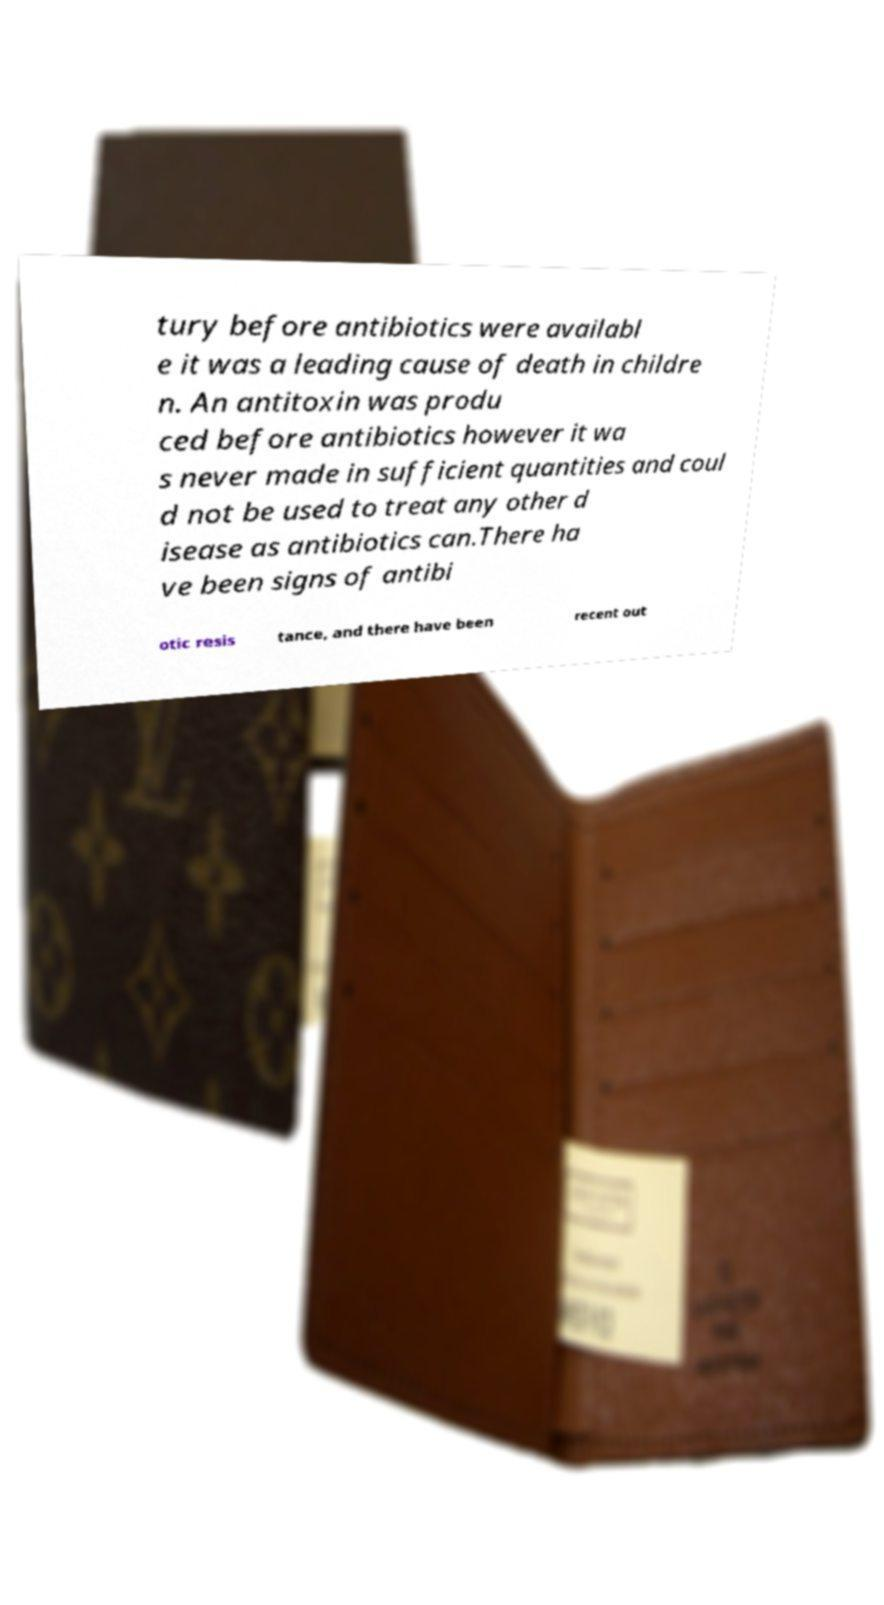I need the written content from this picture converted into text. Can you do that? tury before antibiotics were availabl e it was a leading cause of death in childre n. An antitoxin was produ ced before antibiotics however it wa s never made in sufficient quantities and coul d not be used to treat any other d isease as antibiotics can.There ha ve been signs of antibi otic resis tance, and there have been recent out 